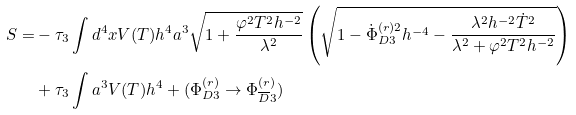<formula> <loc_0><loc_0><loc_500><loc_500>S = & - \tau _ { 3 } \int d ^ { 4 } x V ( T ) h ^ { 4 } a ^ { 3 } \sqrt { 1 + \frac { \varphi ^ { 2 } T ^ { 2 } h ^ { - 2 } } { \lambda ^ { 2 } } } \left ( \sqrt { 1 - \dot { \Phi } ^ { ( r ) 2 } _ { D 3 } h ^ { - 4 } - \frac { \lambda ^ { 2 } h ^ { - 2 } \dot { T } ^ { 2 } } { \lambda ^ { 2 } + \varphi ^ { 2 } T ^ { 2 } h ^ { - 2 } } } \right ) \\ & + \tau _ { 3 } \int a ^ { 3 } V ( T ) h ^ { 4 } + ( \Phi ^ { ( r ) } _ { D 3 } \rightarrow \Phi ^ { ( r ) } _ { \overline { D } 3 } )</formula> 